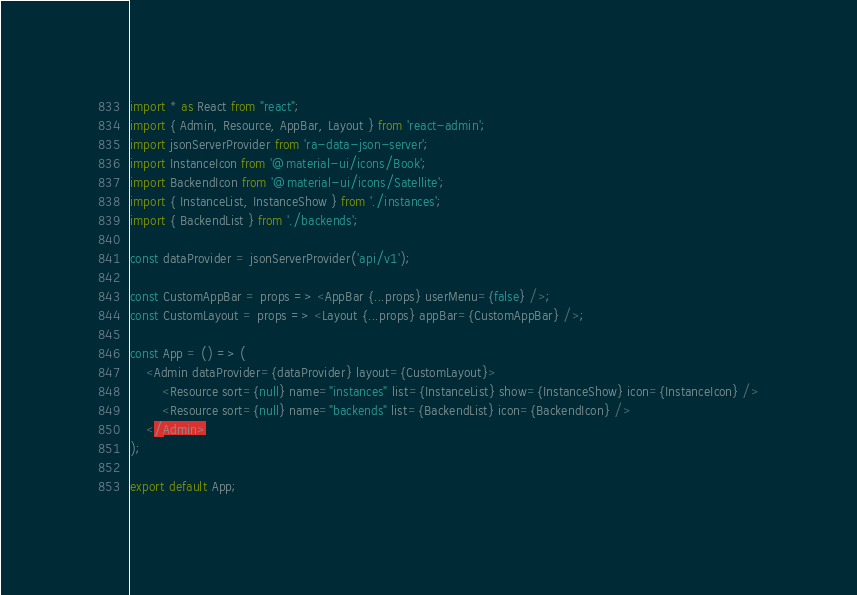Convert code to text. <code><loc_0><loc_0><loc_500><loc_500><_JavaScript_>import * as React from "react";
import { Admin, Resource, AppBar, Layout } from 'react-admin';
import jsonServerProvider from 'ra-data-json-server';
import InstanceIcon from '@material-ui/icons/Book';
import BackendIcon from '@material-ui/icons/Satellite';
import { InstanceList, InstanceShow } from './instances';
import { BackendList } from './backends';

const dataProvider = jsonServerProvider('api/v1');

const CustomAppBar = props => <AppBar {...props} userMenu={false} />;
const CustomLayout = props => <Layout {...props} appBar={CustomAppBar} />;

const App = () => (
    <Admin dataProvider={dataProvider} layout={CustomLayout}>
        <Resource sort={null} name="instances" list={InstanceList} show={InstanceShow} icon={InstanceIcon} />
        <Resource sort={null} name="backends" list={BackendList} icon={BackendIcon} />
    </Admin>
);

export default App;</code> 